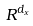Convert formula to latex. <formula><loc_0><loc_0><loc_500><loc_500>R ^ { d _ { x } }</formula> 